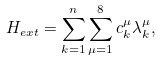<formula> <loc_0><loc_0><loc_500><loc_500>H _ { e x t } = \sum _ { k = 1 } ^ { n } \sum _ { \mu = 1 } ^ { 8 } c _ { k } ^ { \mu } \lambda _ { k } ^ { \mu } ,</formula> 